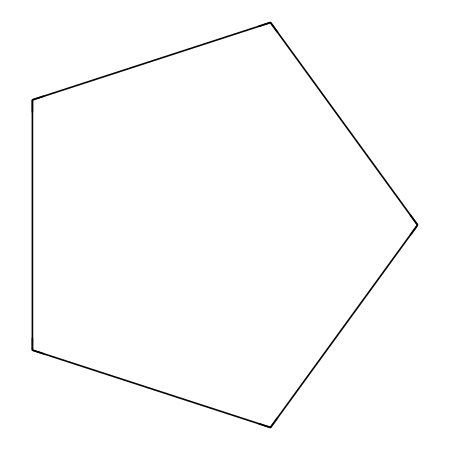What is the molecular formula of cyclopentane? The SMILES representation shows five carbon atoms (C) and the hydrogen atoms associated with them. Cyclopentane has the formula C5H10 because each carbon atom can form a certain number of bonds, and they fill in with hydrogens to complete their tetravalence.
Answer: C5H10 How many carbon atoms are in cyclopentane? By examining the SMILES notation, we can see that there is a 'C' before each carbon in the cyclic structure, indicating a total of five carbon atoms in the structure.
Answer: 5 What type of bonding is present in cyclopentane? Cyclopentane consists solely of single bonds connecting the carbon atoms, as indicated by the absence of any double or triple bond notations in the SMILES.
Answer: single How does the cyclic structure of cyclopentane affect its boiling point? The structure creates a more stable conformation by reducing the surface area compared to straight-chain alkanes, which leads to lower boiling points compared to similar linear alkanes, but higher than smaller alkanes.
Answer: higher What type of compound is cyclopentane? Cyclopentane is classified as a cycloalkane, which is specifically a type of alkane with a closed ring structure made up of carbon atoms.
Answer: cycloalkane How many hydrogen atoms are typically bonded to cyclopentane's carbon atoms? In cyclopentane, each carbon typically bonds to two hydrogen atoms due to the ring structure where each carbon is adjacent to two others and one of its valences is satisfied by another carbon.
Answer: 10 What is the significance of cyclopentane in tire rubber compounds? Cyclopentane is known to enhance the flexibility and durability of rubber compounds used in tires due to its properties as a cycloalkane and its ability to behave like a plasticizer.
Answer: flexibility 